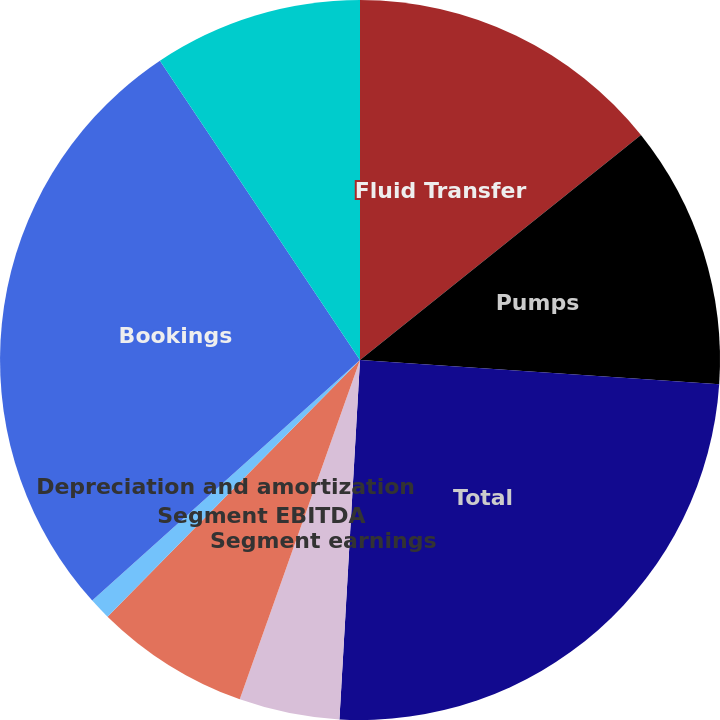Convert chart to OTSL. <chart><loc_0><loc_0><loc_500><loc_500><pie_chart><fcel>Fluid Transfer<fcel>Pumps<fcel>Total<fcel>Segment earnings<fcel>Segment EBITDA<fcel>Depreciation and amortization<fcel>Bookings<fcel>Backlog<nl><fcel>14.25%<fcel>11.82%<fcel>24.84%<fcel>4.51%<fcel>6.95%<fcel>0.98%<fcel>27.27%<fcel>9.38%<nl></chart> 